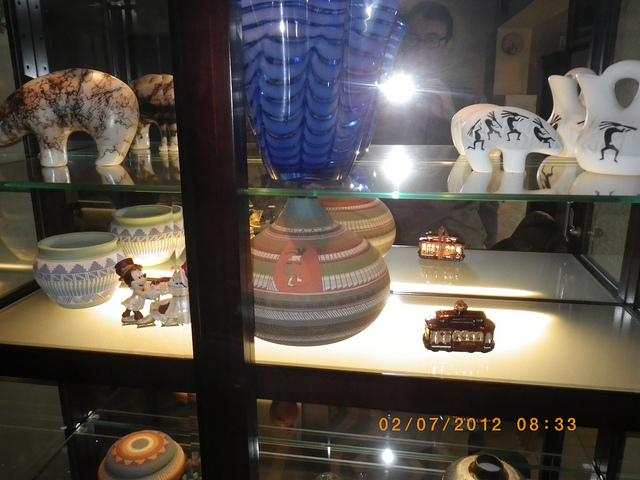Are these items on display?
Keep it brief. Yes. How many antiques are there?
Be succinct. 10. Which shelf is made of glass?
Write a very short answer. Top. 